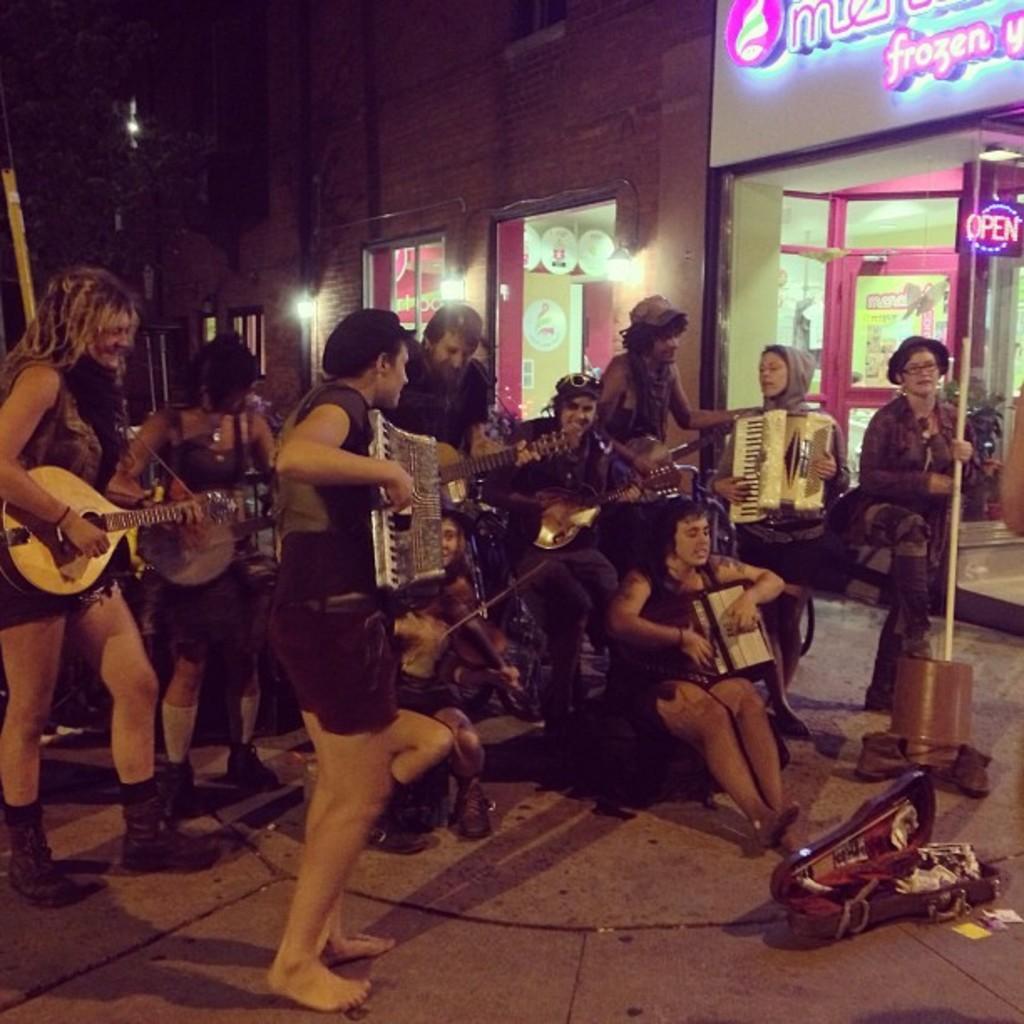Describe this image in one or two sentences. In this image there are so many people sitting and standing and they are playing some musical instruments, there is an object on the surface and few poles. In the background there is the sky. 